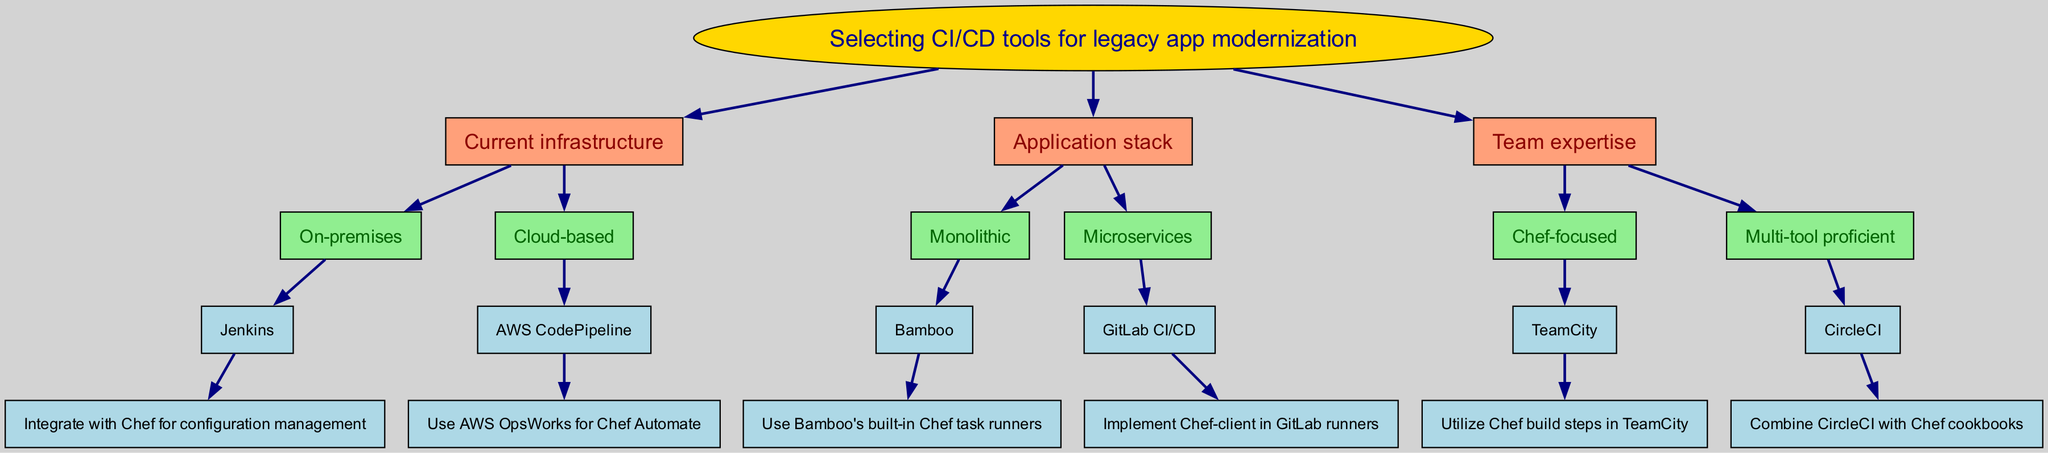What is the root of the decision tree? The root of the decision tree is the starting point and represents the main decision to be made, which in this case is "Selecting CI/CD tools for legacy app modernization."
Answer: Selecting CI/CD tools for legacy app modernization How many main criteria are there in the diagram? The diagram presents three main criteria: Current infrastructure, Application stack, and Team expertise. Each of these criteria represents a branch in the decision tree.
Answer: 3 Which CI/CD tool is suggested for on-premises infrastructure? The diagram indicates that Jenkins is the CI/CD tool recommended for on-premises infrastructure.
Answer: Jenkins What is the recommended tool for microservices? The diagram shows that GitLab CI/CD is the prioritized tool for microservices.
Answer: GitLab CI/CD If a team is Chef-focused, which CI/CD tool would they likely use? According to the diagram, if the team has a Chef-focused expertise, the recommended tool is TeamCity.
Answer: TeamCity What downstream process is associated with AWS CodePipeline? The decision tree indicates that AWS OpsWorks for Chef Automate is the downstream process associated with AWS CodePipeline.
Answer: AWS OpsWorks for Chef Automate Which CI/CD tool is connected to Bamboo? The decision tree states that Bamboo is connected to the monolithic application stack as the suggested CI/CD tool.
Answer: Bamboo How many children does the "Current infrastructure" node have? The "Current infrastructure" node has two children nodes: "On-premises" and "Cloud-based."
Answer: 2 What is the relationship between microservices and GitLab CI/CD? The relationship is that GitLab CI/CD is the recommended CI/CD tool specifically for microservices according to the diagram.
Answer: Recommended CI/CD tool for microservices 